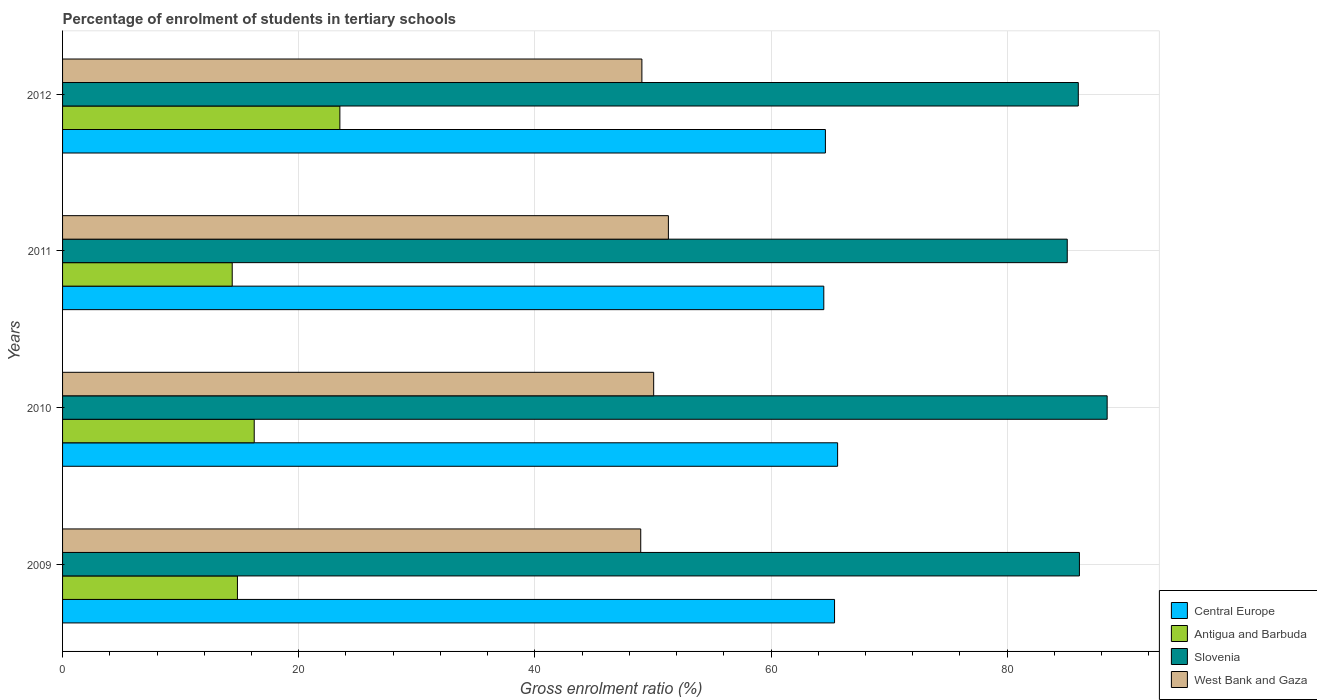Are the number of bars on each tick of the Y-axis equal?
Offer a very short reply. Yes. How many bars are there on the 2nd tick from the bottom?
Your response must be concise. 4. In how many cases, is the number of bars for a given year not equal to the number of legend labels?
Ensure brevity in your answer.  0. What is the percentage of students enrolled in tertiary schools in Slovenia in 2010?
Provide a succinct answer. 88.47. Across all years, what is the maximum percentage of students enrolled in tertiary schools in West Bank and Gaza?
Ensure brevity in your answer.  51.31. Across all years, what is the minimum percentage of students enrolled in tertiary schools in Antigua and Barbuda?
Your response must be concise. 14.37. What is the total percentage of students enrolled in tertiary schools in Slovenia in the graph?
Your response must be concise. 345.7. What is the difference between the percentage of students enrolled in tertiary schools in Antigua and Barbuda in 2009 and that in 2011?
Your answer should be very brief. 0.44. What is the difference between the percentage of students enrolled in tertiary schools in Slovenia in 2009 and the percentage of students enrolled in tertiary schools in Central Europe in 2011?
Provide a succinct answer. 21.65. What is the average percentage of students enrolled in tertiary schools in Central Europe per year?
Keep it short and to the point. 65.02. In the year 2009, what is the difference between the percentage of students enrolled in tertiary schools in Central Europe and percentage of students enrolled in tertiary schools in West Bank and Gaza?
Keep it short and to the point. 16.42. What is the ratio of the percentage of students enrolled in tertiary schools in West Bank and Gaza in 2011 to that in 2012?
Your answer should be very brief. 1.05. Is the difference between the percentage of students enrolled in tertiary schools in Central Europe in 2009 and 2011 greater than the difference between the percentage of students enrolled in tertiary schools in West Bank and Gaza in 2009 and 2011?
Offer a terse response. Yes. What is the difference between the highest and the second highest percentage of students enrolled in tertiary schools in Antigua and Barbuda?
Give a very brief answer. 7.25. What is the difference between the highest and the lowest percentage of students enrolled in tertiary schools in West Bank and Gaza?
Offer a very short reply. 2.34. In how many years, is the percentage of students enrolled in tertiary schools in West Bank and Gaza greater than the average percentage of students enrolled in tertiary schools in West Bank and Gaza taken over all years?
Keep it short and to the point. 2. Is it the case that in every year, the sum of the percentage of students enrolled in tertiary schools in Central Europe and percentage of students enrolled in tertiary schools in Slovenia is greater than the sum of percentage of students enrolled in tertiary schools in West Bank and Gaza and percentage of students enrolled in tertiary schools in Antigua and Barbuda?
Your answer should be compact. Yes. What does the 3rd bar from the top in 2010 represents?
Offer a terse response. Antigua and Barbuda. What does the 1st bar from the bottom in 2011 represents?
Your answer should be very brief. Central Europe. Are the values on the major ticks of X-axis written in scientific E-notation?
Offer a terse response. No. Does the graph contain grids?
Provide a succinct answer. Yes. What is the title of the graph?
Ensure brevity in your answer.  Percentage of enrolment of students in tertiary schools. What is the Gross enrolment ratio (%) of Central Europe in 2009?
Provide a succinct answer. 65.38. What is the Gross enrolment ratio (%) in Antigua and Barbuda in 2009?
Provide a short and direct response. 14.81. What is the Gross enrolment ratio (%) in Slovenia in 2009?
Offer a very short reply. 86.12. What is the Gross enrolment ratio (%) of West Bank and Gaza in 2009?
Offer a very short reply. 48.97. What is the Gross enrolment ratio (%) of Central Europe in 2010?
Your response must be concise. 65.64. What is the Gross enrolment ratio (%) of Antigua and Barbuda in 2010?
Make the answer very short. 16.23. What is the Gross enrolment ratio (%) in Slovenia in 2010?
Give a very brief answer. 88.47. What is the Gross enrolment ratio (%) of West Bank and Gaza in 2010?
Ensure brevity in your answer.  50.06. What is the Gross enrolment ratio (%) of Central Europe in 2011?
Provide a succinct answer. 64.47. What is the Gross enrolment ratio (%) in Antigua and Barbuda in 2011?
Give a very brief answer. 14.37. What is the Gross enrolment ratio (%) of Slovenia in 2011?
Keep it short and to the point. 85.09. What is the Gross enrolment ratio (%) of West Bank and Gaza in 2011?
Your response must be concise. 51.31. What is the Gross enrolment ratio (%) of Central Europe in 2012?
Ensure brevity in your answer.  64.61. What is the Gross enrolment ratio (%) in Antigua and Barbuda in 2012?
Your answer should be very brief. 23.49. What is the Gross enrolment ratio (%) of Slovenia in 2012?
Provide a succinct answer. 86.02. What is the Gross enrolment ratio (%) in West Bank and Gaza in 2012?
Offer a very short reply. 49.06. Across all years, what is the maximum Gross enrolment ratio (%) in Central Europe?
Your response must be concise. 65.64. Across all years, what is the maximum Gross enrolment ratio (%) in Antigua and Barbuda?
Offer a very short reply. 23.49. Across all years, what is the maximum Gross enrolment ratio (%) of Slovenia?
Keep it short and to the point. 88.47. Across all years, what is the maximum Gross enrolment ratio (%) of West Bank and Gaza?
Offer a very short reply. 51.31. Across all years, what is the minimum Gross enrolment ratio (%) in Central Europe?
Offer a very short reply. 64.47. Across all years, what is the minimum Gross enrolment ratio (%) of Antigua and Barbuda?
Give a very brief answer. 14.37. Across all years, what is the minimum Gross enrolment ratio (%) of Slovenia?
Offer a terse response. 85.09. Across all years, what is the minimum Gross enrolment ratio (%) of West Bank and Gaza?
Ensure brevity in your answer.  48.97. What is the total Gross enrolment ratio (%) of Central Europe in the graph?
Make the answer very short. 260.1. What is the total Gross enrolment ratio (%) in Antigua and Barbuda in the graph?
Offer a very short reply. 68.9. What is the total Gross enrolment ratio (%) of Slovenia in the graph?
Give a very brief answer. 345.7. What is the total Gross enrolment ratio (%) of West Bank and Gaza in the graph?
Make the answer very short. 199.4. What is the difference between the Gross enrolment ratio (%) in Central Europe in 2009 and that in 2010?
Offer a terse response. -0.26. What is the difference between the Gross enrolment ratio (%) in Antigua and Barbuda in 2009 and that in 2010?
Give a very brief answer. -1.42. What is the difference between the Gross enrolment ratio (%) of Slovenia in 2009 and that in 2010?
Provide a short and direct response. -2.35. What is the difference between the Gross enrolment ratio (%) in West Bank and Gaza in 2009 and that in 2010?
Ensure brevity in your answer.  -1.1. What is the difference between the Gross enrolment ratio (%) of Central Europe in 2009 and that in 2011?
Ensure brevity in your answer.  0.91. What is the difference between the Gross enrolment ratio (%) of Antigua and Barbuda in 2009 and that in 2011?
Offer a terse response. 0.44. What is the difference between the Gross enrolment ratio (%) of Slovenia in 2009 and that in 2011?
Give a very brief answer. 1.03. What is the difference between the Gross enrolment ratio (%) in West Bank and Gaza in 2009 and that in 2011?
Make the answer very short. -2.34. What is the difference between the Gross enrolment ratio (%) of Central Europe in 2009 and that in 2012?
Your answer should be compact. 0.78. What is the difference between the Gross enrolment ratio (%) of Antigua and Barbuda in 2009 and that in 2012?
Provide a succinct answer. -8.68. What is the difference between the Gross enrolment ratio (%) in Slovenia in 2009 and that in 2012?
Your answer should be very brief. 0.09. What is the difference between the Gross enrolment ratio (%) in West Bank and Gaza in 2009 and that in 2012?
Your response must be concise. -0.1. What is the difference between the Gross enrolment ratio (%) in Central Europe in 2010 and that in 2011?
Your response must be concise. 1.17. What is the difference between the Gross enrolment ratio (%) of Antigua and Barbuda in 2010 and that in 2011?
Give a very brief answer. 1.86. What is the difference between the Gross enrolment ratio (%) of Slovenia in 2010 and that in 2011?
Provide a succinct answer. 3.38. What is the difference between the Gross enrolment ratio (%) in West Bank and Gaza in 2010 and that in 2011?
Make the answer very short. -1.25. What is the difference between the Gross enrolment ratio (%) in Central Europe in 2010 and that in 2012?
Your answer should be very brief. 1.03. What is the difference between the Gross enrolment ratio (%) of Antigua and Barbuda in 2010 and that in 2012?
Give a very brief answer. -7.25. What is the difference between the Gross enrolment ratio (%) of Slovenia in 2010 and that in 2012?
Provide a short and direct response. 2.44. What is the difference between the Gross enrolment ratio (%) in Central Europe in 2011 and that in 2012?
Ensure brevity in your answer.  -0.14. What is the difference between the Gross enrolment ratio (%) of Antigua and Barbuda in 2011 and that in 2012?
Give a very brief answer. -9.12. What is the difference between the Gross enrolment ratio (%) of Slovenia in 2011 and that in 2012?
Your response must be concise. -0.94. What is the difference between the Gross enrolment ratio (%) of West Bank and Gaza in 2011 and that in 2012?
Keep it short and to the point. 2.24. What is the difference between the Gross enrolment ratio (%) in Central Europe in 2009 and the Gross enrolment ratio (%) in Antigua and Barbuda in 2010?
Give a very brief answer. 49.15. What is the difference between the Gross enrolment ratio (%) in Central Europe in 2009 and the Gross enrolment ratio (%) in Slovenia in 2010?
Provide a succinct answer. -23.09. What is the difference between the Gross enrolment ratio (%) in Central Europe in 2009 and the Gross enrolment ratio (%) in West Bank and Gaza in 2010?
Provide a succinct answer. 15.32. What is the difference between the Gross enrolment ratio (%) of Antigua and Barbuda in 2009 and the Gross enrolment ratio (%) of Slovenia in 2010?
Offer a very short reply. -73.66. What is the difference between the Gross enrolment ratio (%) of Antigua and Barbuda in 2009 and the Gross enrolment ratio (%) of West Bank and Gaza in 2010?
Provide a succinct answer. -35.25. What is the difference between the Gross enrolment ratio (%) in Slovenia in 2009 and the Gross enrolment ratio (%) in West Bank and Gaza in 2010?
Your answer should be very brief. 36.06. What is the difference between the Gross enrolment ratio (%) in Central Europe in 2009 and the Gross enrolment ratio (%) in Antigua and Barbuda in 2011?
Make the answer very short. 51.01. What is the difference between the Gross enrolment ratio (%) of Central Europe in 2009 and the Gross enrolment ratio (%) of Slovenia in 2011?
Provide a succinct answer. -19.71. What is the difference between the Gross enrolment ratio (%) of Central Europe in 2009 and the Gross enrolment ratio (%) of West Bank and Gaza in 2011?
Offer a very short reply. 14.07. What is the difference between the Gross enrolment ratio (%) in Antigua and Barbuda in 2009 and the Gross enrolment ratio (%) in Slovenia in 2011?
Your response must be concise. -70.28. What is the difference between the Gross enrolment ratio (%) of Antigua and Barbuda in 2009 and the Gross enrolment ratio (%) of West Bank and Gaza in 2011?
Provide a succinct answer. -36.5. What is the difference between the Gross enrolment ratio (%) of Slovenia in 2009 and the Gross enrolment ratio (%) of West Bank and Gaza in 2011?
Your response must be concise. 34.81. What is the difference between the Gross enrolment ratio (%) of Central Europe in 2009 and the Gross enrolment ratio (%) of Antigua and Barbuda in 2012?
Keep it short and to the point. 41.89. What is the difference between the Gross enrolment ratio (%) in Central Europe in 2009 and the Gross enrolment ratio (%) in Slovenia in 2012?
Your response must be concise. -20.64. What is the difference between the Gross enrolment ratio (%) of Central Europe in 2009 and the Gross enrolment ratio (%) of West Bank and Gaza in 2012?
Give a very brief answer. 16.32. What is the difference between the Gross enrolment ratio (%) in Antigua and Barbuda in 2009 and the Gross enrolment ratio (%) in Slovenia in 2012?
Your response must be concise. -71.21. What is the difference between the Gross enrolment ratio (%) in Antigua and Barbuda in 2009 and the Gross enrolment ratio (%) in West Bank and Gaza in 2012?
Give a very brief answer. -34.25. What is the difference between the Gross enrolment ratio (%) of Slovenia in 2009 and the Gross enrolment ratio (%) of West Bank and Gaza in 2012?
Offer a very short reply. 37.05. What is the difference between the Gross enrolment ratio (%) in Central Europe in 2010 and the Gross enrolment ratio (%) in Antigua and Barbuda in 2011?
Offer a very short reply. 51.27. What is the difference between the Gross enrolment ratio (%) in Central Europe in 2010 and the Gross enrolment ratio (%) in Slovenia in 2011?
Make the answer very short. -19.45. What is the difference between the Gross enrolment ratio (%) in Central Europe in 2010 and the Gross enrolment ratio (%) in West Bank and Gaza in 2011?
Give a very brief answer. 14.33. What is the difference between the Gross enrolment ratio (%) of Antigua and Barbuda in 2010 and the Gross enrolment ratio (%) of Slovenia in 2011?
Offer a very short reply. -68.86. What is the difference between the Gross enrolment ratio (%) of Antigua and Barbuda in 2010 and the Gross enrolment ratio (%) of West Bank and Gaza in 2011?
Your answer should be very brief. -35.08. What is the difference between the Gross enrolment ratio (%) in Slovenia in 2010 and the Gross enrolment ratio (%) in West Bank and Gaza in 2011?
Provide a succinct answer. 37.16. What is the difference between the Gross enrolment ratio (%) in Central Europe in 2010 and the Gross enrolment ratio (%) in Antigua and Barbuda in 2012?
Provide a succinct answer. 42.15. What is the difference between the Gross enrolment ratio (%) of Central Europe in 2010 and the Gross enrolment ratio (%) of Slovenia in 2012?
Offer a terse response. -20.39. What is the difference between the Gross enrolment ratio (%) in Central Europe in 2010 and the Gross enrolment ratio (%) in West Bank and Gaza in 2012?
Provide a short and direct response. 16.58. What is the difference between the Gross enrolment ratio (%) in Antigua and Barbuda in 2010 and the Gross enrolment ratio (%) in Slovenia in 2012?
Provide a short and direct response. -69.79. What is the difference between the Gross enrolment ratio (%) of Antigua and Barbuda in 2010 and the Gross enrolment ratio (%) of West Bank and Gaza in 2012?
Keep it short and to the point. -32.83. What is the difference between the Gross enrolment ratio (%) of Slovenia in 2010 and the Gross enrolment ratio (%) of West Bank and Gaza in 2012?
Make the answer very short. 39.4. What is the difference between the Gross enrolment ratio (%) in Central Europe in 2011 and the Gross enrolment ratio (%) in Antigua and Barbuda in 2012?
Ensure brevity in your answer.  40.98. What is the difference between the Gross enrolment ratio (%) in Central Europe in 2011 and the Gross enrolment ratio (%) in Slovenia in 2012?
Offer a terse response. -21.55. What is the difference between the Gross enrolment ratio (%) of Central Europe in 2011 and the Gross enrolment ratio (%) of West Bank and Gaza in 2012?
Your response must be concise. 15.41. What is the difference between the Gross enrolment ratio (%) in Antigua and Barbuda in 2011 and the Gross enrolment ratio (%) in Slovenia in 2012?
Your answer should be very brief. -71.66. What is the difference between the Gross enrolment ratio (%) in Antigua and Barbuda in 2011 and the Gross enrolment ratio (%) in West Bank and Gaza in 2012?
Offer a very short reply. -34.7. What is the difference between the Gross enrolment ratio (%) in Slovenia in 2011 and the Gross enrolment ratio (%) in West Bank and Gaza in 2012?
Your response must be concise. 36.02. What is the average Gross enrolment ratio (%) of Central Europe per year?
Give a very brief answer. 65.02. What is the average Gross enrolment ratio (%) in Antigua and Barbuda per year?
Make the answer very short. 17.22. What is the average Gross enrolment ratio (%) in Slovenia per year?
Offer a terse response. 86.43. What is the average Gross enrolment ratio (%) of West Bank and Gaza per year?
Offer a very short reply. 49.85. In the year 2009, what is the difference between the Gross enrolment ratio (%) of Central Europe and Gross enrolment ratio (%) of Antigua and Barbuda?
Offer a terse response. 50.57. In the year 2009, what is the difference between the Gross enrolment ratio (%) in Central Europe and Gross enrolment ratio (%) in Slovenia?
Provide a short and direct response. -20.74. In the year 2009, what is the difference between the Gross enrolment ratio (%) of Central Europe and Gross enrolment ratio (%) of West Bank and Gaza?
Provide a short and direct response. 16.42. In the year 2009, what is the difference between the Gross enrolment ratio (%) in Antigua and Barbuda and Gross enrolment ratio (%) in Slovenia?
Ensure brevity in your answer.  -71.31. In the year 2009, what is the difference between the Gross enrolment ratio (%) in Antigua and Barbuda and Gross enrolment ratio (%) in West Bank and Gaza?
Provide a short and direct response. -34.16. In the year 2009, what is the difference between the Gross enrolment ratio (%) in Slovenia and Gross enrolment ratio (%) in West Bank and Gaza?
Your response must be concise. 37.15. In the year 2010, what is the difference between the Gross enrolment ratio (%) in Central Europe and Gross enrolment ratio (%) in Antigua and Barbuda?
Give a very brief answer. 49.41. In the year 2010, what is the difference between the Gross enrolment ratio (%) of Central Europe and Gross enrolment ratio (%) of Slovenia?
Your response must be concise. -22.83. In the year 2010, what is the difference between the Gross enrolment ratio (%) of Central Europe and Gross enrolment ratio (%) of West Bank and Gaza?
Your answer should be compact. 15.58. In the year 2010, what is the difference between the Gross enrolment ratio (%) in Antigua and Barbuda and Gross enrolment ratio (%) in Slovenia?
Your answer should be compact. -72.24. In the year 2010, what is the difference between the Gross enrolment ratio (%) in Antigua and Barbuda and Gross enrolment ratio (%) in West Bank and Gaza?
Your response must be concise. -33.83. In the year 2010, what is the difference between the Gross enrolment ratio (%) in Slovenia and Gross enrolment ratio (%) in West Bank and Gaza?
Your answer should be compact. 38.41. In the year 2011, what is the difference between the Gross enrolment ratio (%) in Central Europe and Gross enrolment ratio (%) in Antigua and Barbuda?
Offer a terse response. 50.1. In the year 2011, what is the difference between the Gross enrolment ratio (%) in Central Europe and Gross enrolment ratio (%) in Slovenia?
Make the answer very short. -20.62. In the year 2011, what is the difference between the Gross enrolment ratio (%) in Central Europe and Gross enrolment ratio (%) in West Bank and Gaza?
Give a very brief answer. 13.16. In the year 2011, what is the difference between the Gross enrolment ratio (%) in Antigua and Barbuda and Gross enrolment ratio (%) in Slovenia?
Give a very brief answer. -70.72. In the year 2011, what is the difference between the Gross enrolment ratio (%) in Antigua and Barbuda and Gross enrolment ratio (%) in West Bank and Gaza?
Provide a short and direct response. -36.94. In the year 2011, what is the difference between the Gross enrolment ratio (%) of Slovenia and Gross enrolment ratio (%) of West Bank and Gaza?
Offer a very short reply. 33.78. In the year 2012, what is the difference between the Gross enrolment ratio (%) in Central Europe and Gross enrolment ratio (%) in Antigua and Barbuda?
Give a very brief answer. 41.12. In the year 2012, what is the difference between the Gross enrolment ratio (%) in Central Europe and Gross enrolment ratio (%) in Slovenia?
Provide a short and direct response. -21.42. In the year 2012, what is the difference between the Gross enrolment ratio (%) in Central Europe and Gross enrolment ratio (%) in West Bank and Gaza?
Give a very brief answer. 15.54. In the year 2012, what is the difference between the Gross enrolment ratio (%) in Antigua and Barbuda and Gross enrolment ratio (%) in Slovenia?
Your response must be concise. -62.54. In the year 2012, what is the difference between the Gross enrolment ratio (%) in Antigua and Barbuda and Gross enrolment ratio (%) in West Bank and Gaza?
Provide a succinct answer. -25.58. In the year 2012, what is the difference between the Gross enrolment ratio (%) in Slovenia and Gross enrolment ratio (%) in West Bank and Gaza?
Ensure brevity in your answer.  36.96. What is the ratio of the Gross enrolment ratio (%) in Antigua and Barbuda in 2009 to that in 2010?
Keep it short and to the point. 0.91. What is the ratio of the Gross enrolment ratio (%) in Slovenia in 2009 to that in 2010?
Your answer should be compact. 0.97. What is the ratio of the Gross enrolment ratio (%) of West Bank and Gaza in 2009 to that in 2010?
Ensure brevity in your answer.  0.98. What is the ratio of the Gross enrolment ratio (%) of Central Europe in 2009 to that in 2011?
Provide a succinct answer. 1.01. What is the ratio of the Gross enrolment ratio (%) in Antigua and Barbuda in 2009 to that in 2011?
Provide a succinct answer. 1.03. What is the ratio of the Gross enrolment ratio (%) of Slovenia in 2009 to that in 2011?
Make the answer very short. 1.01. What is the ratio of the Gross enrolment ratio (%) of West Bank and Gaza in 2009 to that in 2011?
Give a very brief answer. 0.95. What is the ratio of the Gross enrolment ratio (%) of Central Europe in 2009 to that in 2012?
Offer a terse response. 1.01. What is the ratio of the Gross enrolment ratio (%) in Antigua and Barbuda in 2009 to that in 2012?
Your answer should be very brief. 0.63. What is the ratio of the Gross enrolment ratio (%) of Slovenia in 2009 to that in 2012?
Make the answer very short. 1. What is the ratio of the Gross enrolment ratio (%) of West Bank and Gaza in 2009 to that in 2012?
Make the answer very short. 1. What is the ratio of the Gross enrolment ratio (%) in Central Europe in 2010 to that in 2011?
Ensure brevity in your answer.  1.02. What is the ratio of the Gross enrolment ratio (%) of Antigua and Barbuda in 2010 to that in 2011?
Offer a terse response. 1.13. What is the ratio of the Gross enrolment ratio (%) of Slovenia in 2010 to that in 2011?
Keep it short and to the point. 1.04. What is the ratio of the Gross enrolment ratio (%) of West Bank and Gaza in 2010 to that in 2011?
Ensure brevity in your answer.  0.98. What is the ratio of the Gross enrolment ratio (%) in Antigua and Barbuda in 2010 to that in 2012?
Your response must be concise. 0.69. What is the ratio of the Gross enrolment ratio (%) of Slovenia in 2010 to that in 2012?
Offer a very short reply. 1.03. What is the ratio of the Gross enrolment ratio (%) in West Bank and Gaza in 2010 to that in 2012?
Ensure brevity in your answer.  1.02. What is the ratio of the Gross enrolment ratio (%) of Antigua and Barbuda in 2011 to that in 2012?
Give a very brief answer. 0.61. What is the ratio of the Gross enrolment ratio (%) in Slovenia in 2011 to that in 2012?
Your response must be concise. 0.99. What is the ratio of the Gross enrolment ratio (%) of West Bank and Gaza in 2011 to that in 2012?
Ensure brevity in your answer.  1.05. What is the difference between the highest and the second highest Gross enrolment ratio (%) of Central Europe?
Provide a succinct answer. 0.26. What is the difference between the highest and the second highest Gross enrolment ratio (%) in Antigua and Barbuda?
Offer a terse response. 7.25. What is the difference between the highest and the second highest Gross enrolment ratio (%) in Slovenia?
Keep it short and to the point. 2.35. What is the difference between the highest and the second highest Gross enrolment ratio (%) in West Bank and Gaza?
Make the answer very short. 1.25. What is the difference between the highest and the lowest Gross enrolment ratio (%) of Central Europe?
Give a very brief answer. 1.17. What is the difference between the highest and the lowest Gross enrolment ratio (%) in Antigua and Barbuda?
Give a very brief answer. 9.12. What is the difference between the highest and the lowest Gross enrolment ratio (%) in Slovenia?
Ensure brevity in your answer.  3.38. What is the difference between the highest and the lowest Gross enrolment ratio (%) in West Bank and Gaza?
Provide a succinct answer. 2.34. 